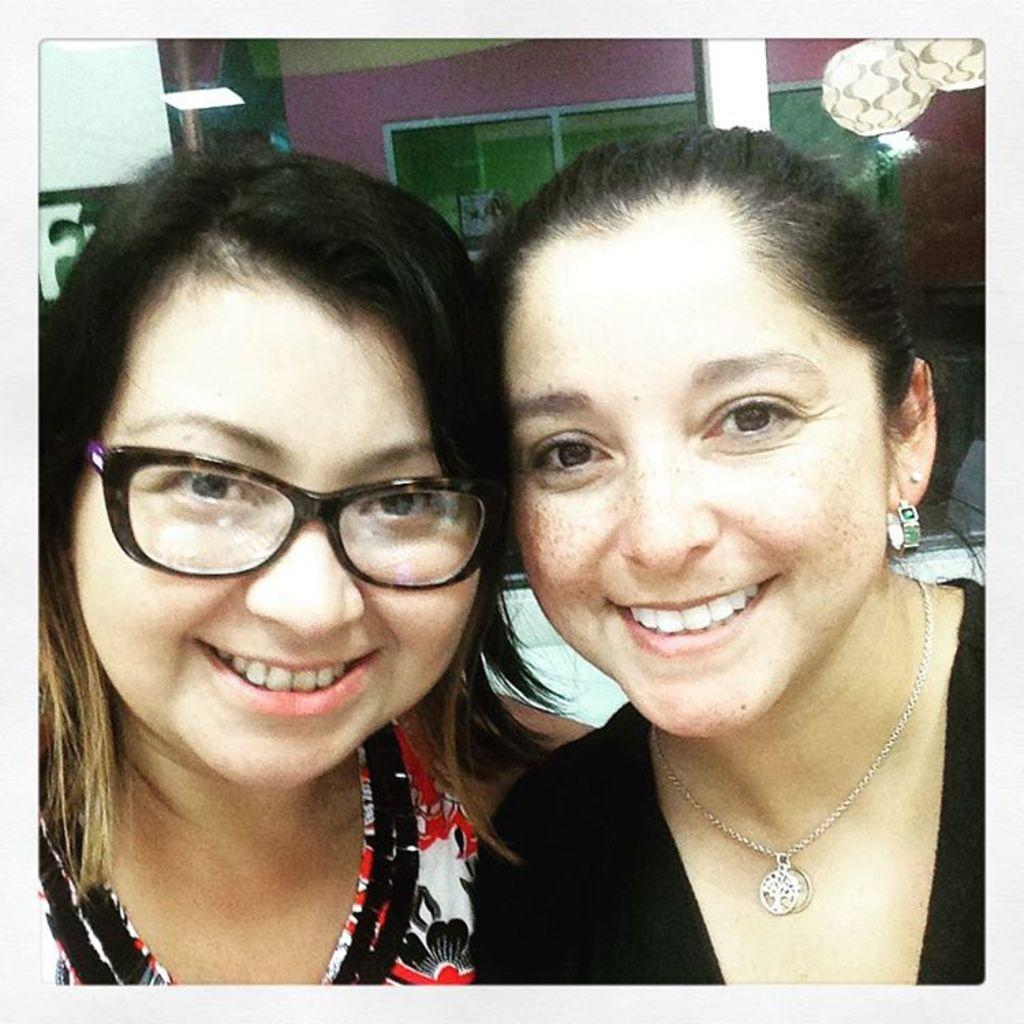How many women are in the image? There are two women in the image. What expressions do the women have? Both women are smiling. Can you describe one of the women's appearance? One of the women is wearing glasses. What can be seen in the background of the image? There is a wall, glass windows, a pillar, and lights visible in the background of the image. Where is the throne located in the image? There is no throne present in the image. How many chickens can be seen in the image? There are no chickens present in the image. 